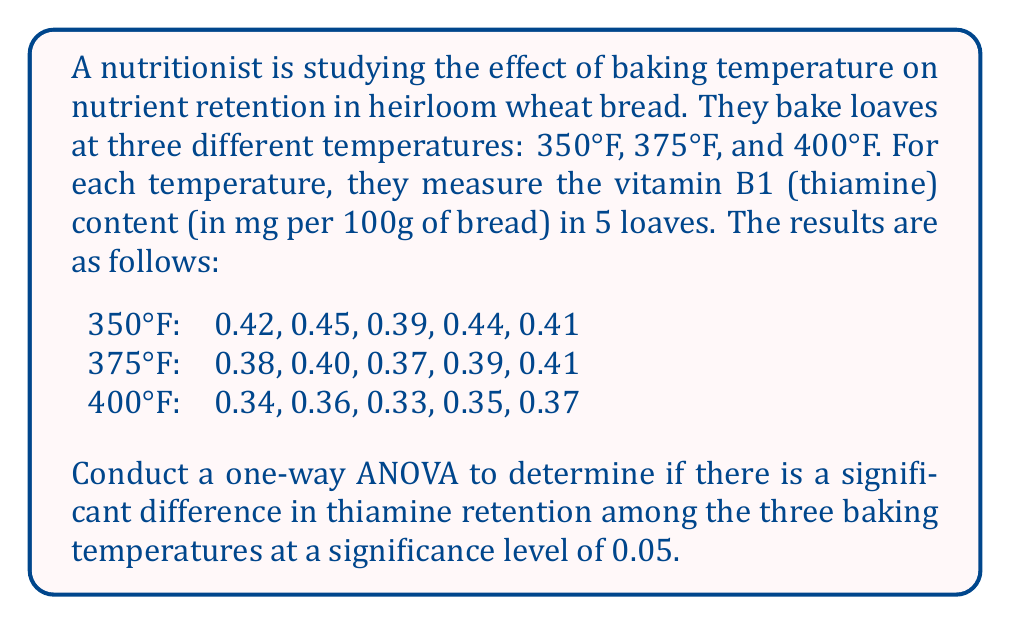Can you answer this question? To conduct a one-way ANOVA, we'll follow these steps:

1. Calculate the sum of squares between groups (SSB), within groups (SSW), and total (SST).
2. Calculate the degrees of freedom for between groups (dfB), within groups (dfW), and total (dfT).
3. Calculate the mean squares for between groups (MSB) and within groups (MSW).
4. Calculate the F-statistic.
5. Compare the F-statistic to the critical F-value.

Step 1: Calculate sum of squares

First, we need to calculate the grand mean:
$$ \bar{X} = \frac{0.42 + 0.45 + ... + 0.35 + 0.37}{15} = 0.388 $$

Now, we can calculate SSB, SSW, and SST:

SSB:
$$ SSB = 5[(0.422 - 0.388)^2 + (0.390 - 0.388)^2 + (0.350 - 0.388)^2] = 0.01572 $$

SSW:
$$ SSW = [(0.42 - 0.422)^2 + (0.45 - 0.422)^2 + ...] = 0.00268 $$

SST:
$$ SST = SSB + SSW = 0.01572 + 0.00268 = 0.01840 $$

Step 2: Calculate degrees of freedom

$$ df_B = k - 1 = 3 - 1 = 2 $$
$$ df_W = N - k = 15 - 3 = 12 $$
$$ df_T = N - 1 = 15 - 1 = 14 $$

Where k is the number of groups and N is the total number of observations.

Step 3: Calculate mean squares

$$ MSB = \frac{SSB}{df_B} = \frac{0.01572}{2} = 0.00786 $$
$$ MSW = \frac{SSW}{df_W} = \frac{0.00268}{12} = 0.000223 $$

Step 4: Calculate F-statistic

$$ F = \frac{MSB}{MSW} = \frac{0.00786}{0.000223} = 35.25 $$

Step 5: Compare F-statistic to critical F-value

The critical F-value for $\alpha = 0.05$, $df_B = 2$, and $df_W = 12$ is approximately 3.89.

Since our calculated F-statistic (35.25) is greater than the critical F-value (3.89), we reject the null hypothesis.
Answer: At a significance level of 0.05, there is strong evidence to conclude that there is a significant difference in thiamine retention among the three baking temperatures (F(2,12) = 35.25, p < 0.05). 